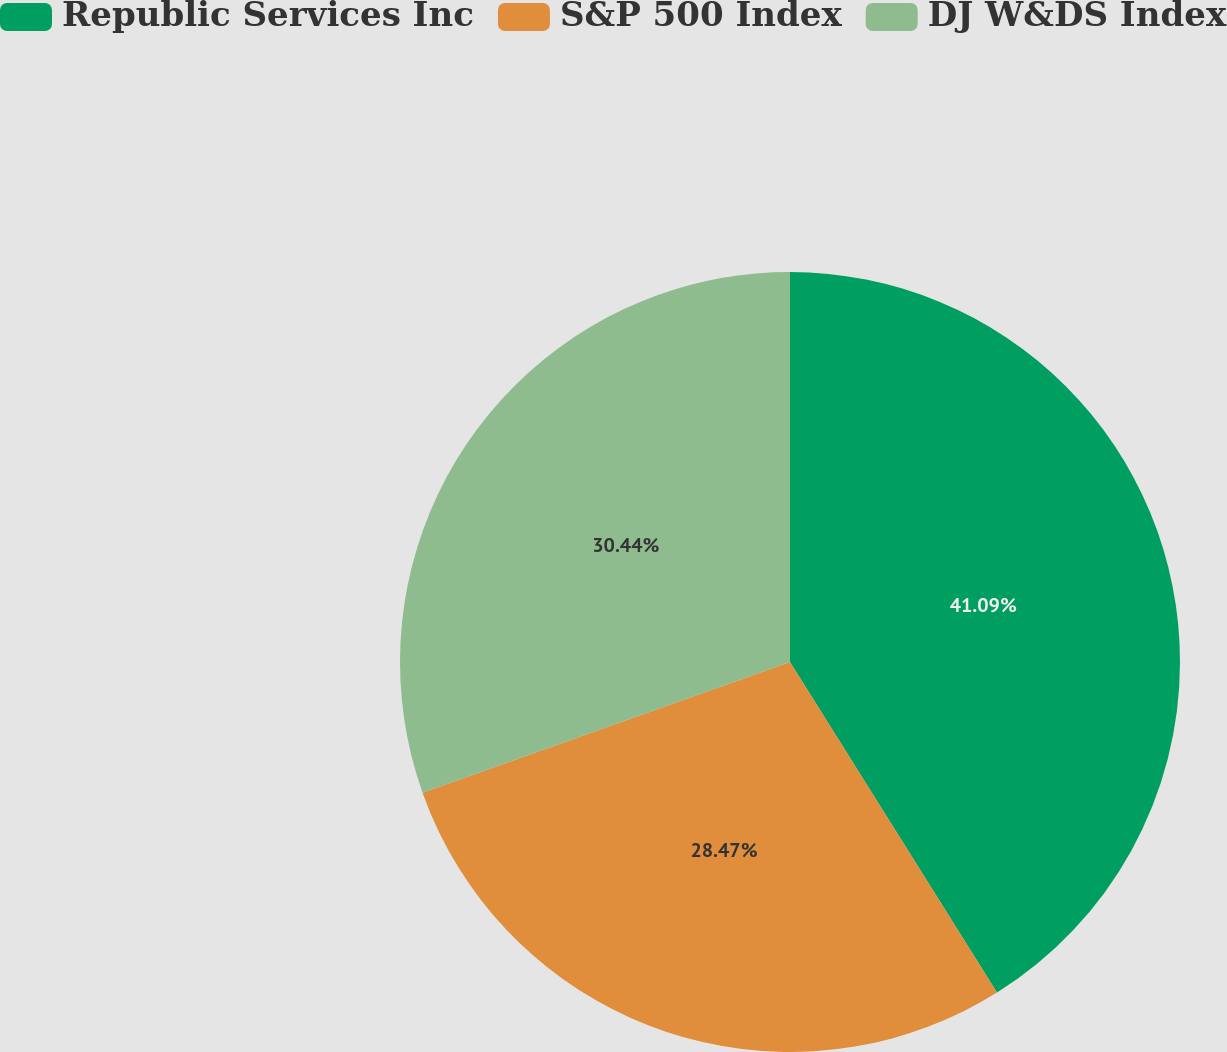<chart> <loc_0><loc_0><loc_500><loc_500><pie_chart><fcel>Republic Services Inc<fcel>S&P 500 Index<fcel>DJ W&DS Index<nl><fcel>41.1%<fcel>28.47%<fcel>30.44%<nl></chart> 